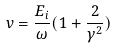Convert formula to latex. <formula><loc_0><loc_0><loc_500><loc_500>v = \frac { E _ { i } } { \omega } ( 1 + \frac { 2 } { \gamma ^ { 2 } } )</formula> 